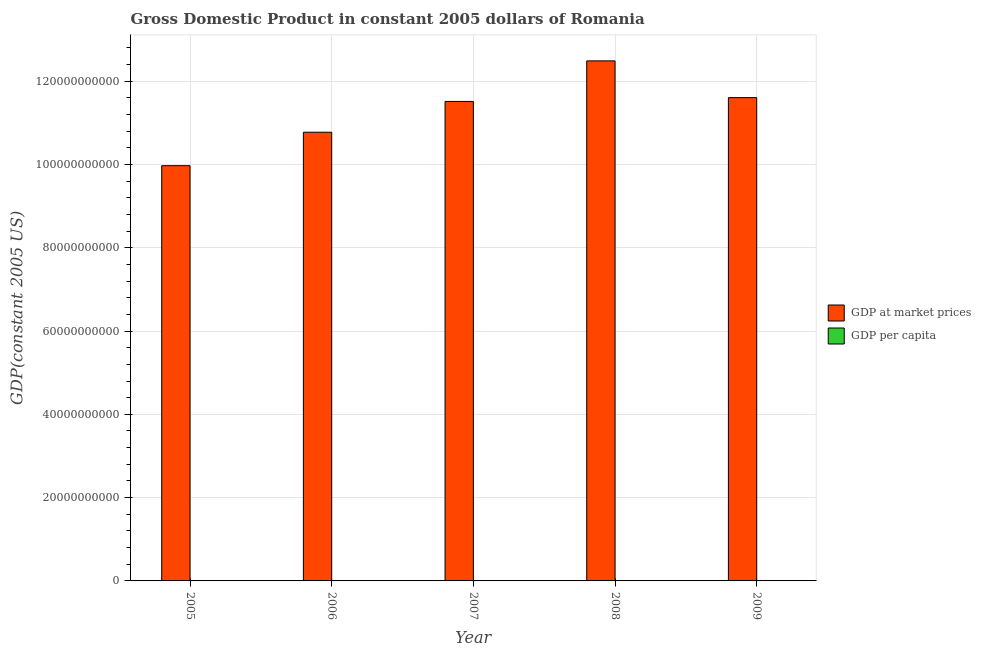How many different coloured bars are there?
Offer a very short reply. 2. Are the number of bars per tick equal to the number of legend labels?
Give a very brief answer. Yes. How many bars are there on the 2nd tick from the left?
Keep it short and to the point. 2. What is the label of the 5th group of bars from the left?
Your answer should be very brief. 2009. In how many cases, is the number of bars for a given year not equal to the number of legend labels?
Give a very brief answer. 0. What is the gdp per capita in 2009?
Your response must be concise. 5697.19. Across all years, what is the maximum gdp at market prices?
Provide a succinct answer. 1.25e+11. Across all years, what is the minimum gdp per capita?
Provide a short and direct response. 4676.32. In which year was the gdp per capita maximum?
Provide a succinct answer. 2008. What is the total gdp at market prices in the graph?
Your answer should be very brief. 5.63e+11. What is the difference between the gdp per capita in 2005 and that in 2009?
Provide a succinct answer. -1020.88. What is the difference between the gdp at market prices in 2005 and the gdp per capita in 2006?
Make the answer very short. -8.03e+09. What is the average gdp at market prices per year?
Your answer should be compact. 1.13e+11. What is the ratio of the gdp at market prices in 2006 to that in 2009?
Ensure brevity in your answer.  0.93. Is the gdp at market prices in 2005 less than that in 2008?
Provide a short and direct response. Yes. What is the difference between the highest and the second highest gdp at market prices?
Make the answer very short. 8.82e+09. What is the difference between the highest and the lowest gdp at market prices?
Your response must be concise. 2.52e+1. In how many years, is the gdp per capita greater than the average gdp per capita taken over all years?
Offer a very short reply. 3. Is the sum of the gdp at market prices in 2007 and 2008 greater than the maximum gdp per capita across all years?
Give a very brief answer. Yes. What does the 1st bar from the left in 2007 represents?
Your answer should be very brief. GDP at market prices. What does the 2nd bar from the right in 2009 represents?
Your answer should be compact. GDP at market prices. How many years are there in the graph?
Make the answer very short. 5. What is the title of the graph?
Ensure brevity in your answer.  Gross Domestic Product in constant 2005 dollars of Romania. Does "Transport services" appear as one of the legend labels in the graph?
Offer a terse response. No. What is the label or title of the Y-axis?
Offer a terse response. GDP(constant 2005 US). What is the GDP(constant 2005 US) of GDP at market prices in 2005?
Your answer should be very brief. 9.97e+1. What is the GDP(constant 2005 US) in GDP per capita in 2005?
Ensure brevity in your answer.  4676.32. What is the GDP(constant 2005 US) in GDP at market prices in 2006?
Give a very brief answer. 1.08e+11. What is the GDP(constant 2005 US) in GDP per capita in 2006?
Offer a terse response. 5083.04. What is the GDP(constant 2005 US) of GDP at market prices in 2007?
Give a very brief answer. 1.15e+11. What is the GDP(constant 2005 US) in GDP per capita in 2007?
Make the answer very short. 5512.77. What is the GDP(constant 2005 US) in GDP at market prices in 2008?
Offer a terse response. 1.25e+11. What is the GDP(constant 2005 US) in GDP per capita in 2008?
Offer a very short reply. 6079.56. What is the GDP(constant 2005 US) of GDP at market prices in 2009?
Provide a succinct answer. 1.16e+11. What is the GDP(constant 2005 US) of GDP per capita in 2009?
Your answer should be very brief. 5697.19. Across all years, what is the maximum GDP(constant 2005 US) of GDP at market prices?
Your response must be concise. 1.25e+11. Across all years, what is the maximum GDP(constant 2005 US) in GDP per capita?
Give a very brief answer. 6079.56. Across all years, what is the minimum GDP(constant 2005 US) of GDP at market prices?
Ensure brevity in your answer.  9.97e+1. Across all years, what is the minimum GDP(constant 2005 US) in GDP per capita?
Keep it short and to the point. 4676.32. What is the total GDP(constant 2005 US) of GDP at market prices in the graph?
Provide a succinct answer. 5.63e+11. What is the total GDP(constant 2005 US) in GDP per capita in the graph?
Provide a succinct answer. 2.70e+04. What is the difference between the GDP(constant 2005 US) of GDP at market prices in 2005 and that in 2006?
Keep it short and to the point. -8.03e+09. What is the difference between the GDP(constant 2005 US) of GDP per capita in 2005 and that in 2006?
Your answer should be compact. -406.73. What is the difference between the GDP(constant 2005 US) of GDP at market prices in 2005 and that in 2007?
Make the answer very short. -1.54e+1. What is the difference between the GDP(constant 2005 US) in GDP per capita in 2005 and that in 2007?
Keep it short and to the point. -836.45. What is the difference between the GDP(constant 2005 US) of GDP at market prices in 2005 and that in 2008?
Your response must be concise. -2.52e+1. What is the difference between the GDP(constant 2005 US) in GDP per capita in 2005 and that in 2008?
Your response must be concise. -1403.24. What is the difference between the GDP(constant 2005 US) of GDP at market prices in 2005 and that in 2009?
Your answer should be compact. -1.63e+1. What is the difference between the GDP(constant 2005 US) of GDP per capita in 2005 and that in 2009?
Offer a terse response. -1020.88. What is the difference between the GDP(constant 2005 US) of GDP at market prices in 2006 and that in 2007?
Provide a succinct answer. -7.39e+09. What is the difference between the GDP(constant 2005 US) in GDP per capita in 2006 and that in 2007?
Ensure brevity in your answer.  -429.73. What is the difference between the GDP(constant 2005 US) in GDP at market prices in 2006 and that in 2008?
Offer a very short reply. -1.71e+1. What is the difference between the GDP(constant 2005 US) in GDP per capita in 2006 and that in 2008?
Make the answer very short. -996.52. What is the difference between the GDP(constant 2005 US) in GDP at market prices in 2006 and that in 2009?
Your answer should be very brief. -8.31e+09. What is the difference between the GDP(constant 2005 US) of GDP per capita in 2006 and that in 2009?
Your answer should be very brief. -614.15. What is the difference between the GDP(constant 2005 US) of GDP at market prices in 2007 and that in 2008?
Make the answer very short. -9.74e+09. What is the difference between the GDP(constant 2005 US) in GDP per capita in 2007 and that in 2008?
Provide a short and direct response. -566.79. What is the difference between the GDP(constant 2005 US) of GDP at market prices in 2007 and that in 2009?
Keep it short and to the point. -9.15e+08. What is the difference between the GDP(constant 2005 US) of GDP per capita in 2007 and that in 2009?
Your answer should be very brief. -184.43. What is the difference between the GDP(constant 2005 US) of GDP at market prices in 2008 and that in 2009?
Give a very brief answer. 8.82e+09. What is the difference between the GDP(constant 2005 US) in GDP per capita in 2008 and that in 2009?
Your response must be concise. 382.37. What is the difference between the GDP(constant 2005 US) of GDP at market prices in 2005 and the GDP(constant 2005 US) of GDP per capita in 2006?
Provide a succinct answer. 9.97e+1. What is the difference between the GDP(constant 2005 US) in GDP at market prices in 2005 and the GDP(constant 2005 US) in GDP per capita in 2007?
Your answer should be compact. 9.97e+1. What is the difference between the GDP(constant 2005 US) in GDP at market prices in 2005 and the GDP(constant 2005 US) in GDP per capita in 2008?
Your answer should be very brief. 9.97e+1. What is the difference between the GDP(constant 2005 US) of GDP at market prices in 2005 and the GDP(constant 2005 US) of GDP per capita in 2009?
Offer a very short reply. 9.97e+1. What is the difference between the GDP(constant 2005 US) in GDP at market prices in 2006 and the GDP(constant 2005 US) in GDP per capita in 2007?
Your answer should be very brief. 1.08e+11. What is the difference between the GDP(constant 2005 US) of GDP at market prices in 2006 and the GDP(constant 2005 US) of GDP per capita in 2008?
Offer a very short reply. 1.08e+11. What is the difference between the GDP(constant 2005 US) in GDP at market prices in 2006 and the GDP(constant 2005 US) in GDP per capita in 2009?
Give a very brief answer. 1.08e+11. What is the difference between the GDP(constant 2005 US) in GDP at market prices in 2007 and the GDP(constant 2005 US) in GDP per capita in 2008?
Your response must be concise. 1.15e+11. What is the difference between the GDP(constant 2005 US) of GDP at market prices in 2007 and the GDP(constant 2005 US) of GDP per capita in 2009?
Provide a short and direct response. 1.15e+11. What is the difference between the GDP(constant 2005 US) of GDP at market prices in 2008 and the GDP(constant 2005 US) of GDP per capita in 2009?
Make the answer very short. 1.25e+11. What is the average GDP(constant 2005 US) of GDP at market prices per year?
Provide a short and direct response. 1.13e+11. What is the average GDP(constant 2005 US) in GDP per capita per year?
Give a very brief answer. 5409.78. In the year 2005, what is the difference between the GDP(constant 2005 US) in GDP at market prices and GDP(constant 2005 US) in GDP per capita?
Provide a short and direct response. 9.97e+1. In the year 2006, what is the difference between the GDP(constant 2005 US) of GDP at market prices and GDP(constant 2005 US) of GDP per capita?
Make the answer very short. 1.08e+11. In the year 2007, what is the difference between the GDP(constant 2005 US) in GDP at market prices and GDP(constant 2005 US) in GDP per capita?
Your answer should be very brief. 1.15e+11. In the year 2008, what is the difference between the GDP(constant 2005 US) in GDP at market prices and GDP(constant 2005 US) in GDP per capita?
Make the answer very short. 1.25e+11. In the year 2009, what is the difference between the GDP(constant 2005 US) in GDP at market prices and GDP(constant 2005 US) in GDP per capita?
Your response must be concise. 1.16e+11. What is the ratio of the GDP(constant 2005 US) of GDP at market prices in 2005 to that in 2006?
Offer a terse response. 0.93. What is the ratio of the GDP(constant 2005 US) in GDP at market prices in 2005 to that in 2007?
Your response must be concise. 0.87. What is the ratio of the GDP(constant 2005 US) of GDP per capita in 2005 to that in 2007?
Ensure brevity in your answer.  0.85. What is the ratio of the GDP(constant 2005 US) of GDP at market prices in 2005 to that in 2008?
Provide a short and direct response. 0.8. What is the ratio of the GDP(constant 2005 US) in GDP per capita in 2005 to that in 2008?
Offer a terse response. 0.77. What is the ratio of the GDP(constant 2005 US) in GDP at market prices in 2005 to that in 2009?
Make the answer very short. 0.86. What is the ratio of the GDP(constant 2005 US) in GDP per capita in 2005 to that in 2009?
Give a very brief answer. 0.82. What is the ratio of the GDP(constant 2005 US) in GDP at market prices in 2006 to that in 2007?
Ensure brevity in your answer.  0.94. What is the ratio of the GDP(constant 2005 US) in GDP per capita in 2006 to that in 2007?
Your response must be concise. 0.92. What is the ratio of the GDP(constant 2005 US) in GDP at market prices in 2006 to that in 2008?
Make the answer very short. 0.86. What is the ratio of the GDP(constant 2005 US) in GDP per capita in 2006 to that in 2008?
Provide a succinct answer. 0.84. What is the ratio of the GDP(constant 2005 US) of GDP at market prices in 2006 to that in 2009?
Provide a succinct answer. 0.93. What is the ratio of the GDP(constant 2005 US) in GDP per capita in 2006 to that in 2009?
Your answer should be very brief. 0.89. What is the ratio of the GDP(constant 2005 US) in GDP at market prices in 2007 to that in 2008?
Your answer should be compact. 0.92. What is the ratio of the GDP(constant 2005 US) of GDP per capita in 2007 to that in 2008?
Your answer should be compact. 0.91. What is the ratio of the GDP(constant 2005 US) of GDP at market prices in 2007 to that in 2009?
Provide a succinct answer. 0.99. What is the ratio of the GDP(constant 2005 US) of GDP per capita in 2007 to that in 2009?
Offer a very short reply. 0.97. What is the ratio of the GDP(constant 2005 US) in GDP at market prices in 2008 to that in 2009?
Provide a short and direct response. 1.08. What is the ratio of the GDP(constant 2005 US) of GDP per capita in 2008 to that in 2009?
Your answer should be compact. 1.07. What is the difference between the highest and the second highest GDP(constant 2005 US) in GDP at market prices?
Your answer should be very brief. 8.82e+09. What is the difference between the highest and the second highest GDP(constant 2005 US) in GDP per capita?
Your response must be concise. 382.37. What is the difference between the highest and the lowest GDP(constant 2005 US) of GDP at market prices?
Provide a succinct answer. 2.52e+1. What is the difference between the highest and the lowest GDP(constant 2005 US) in GDP per capita?
Ensure brevity in your answer.  1403.24. 